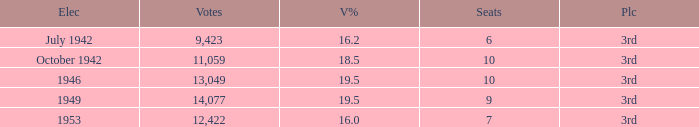Name the vote % for seats of 9 19.5. 